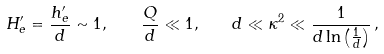Convert formula to latex. <formula><loc_0><loc_0><loc_500><loc_500>H ^ { \prime } _ { e } = \frac { h ^ { \prime } _ { e } } { d } \sim 1 , \quad \frac { Q } { d } \ll 1 , \quad d \ll \kappa ^ { 2 } \ll \frac { 1 } { d \ln \left ( \frac { 1 } { d } \right ) } \, ,</formula> 